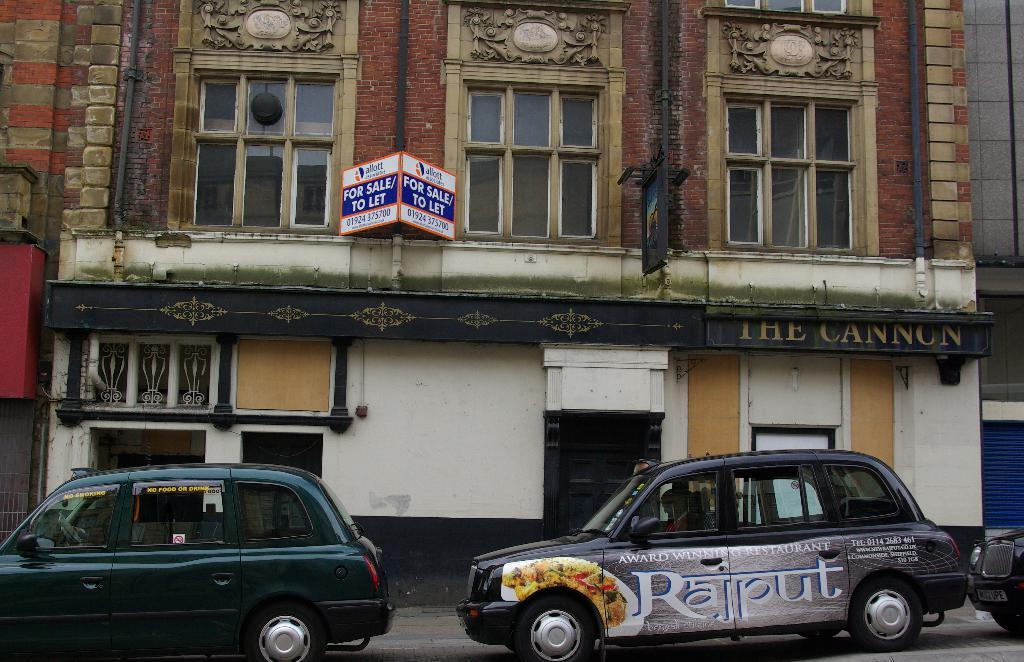<image>
Summarize the visual content of the image. A row of parked cars are next to a building that says For Sale. 